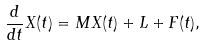<formula> <loc_0><loc_0><loc_500><loc_500>\frac { d } { d t } X ( t ) = M X ( t ) + L + F ( t ) ,</formula> 